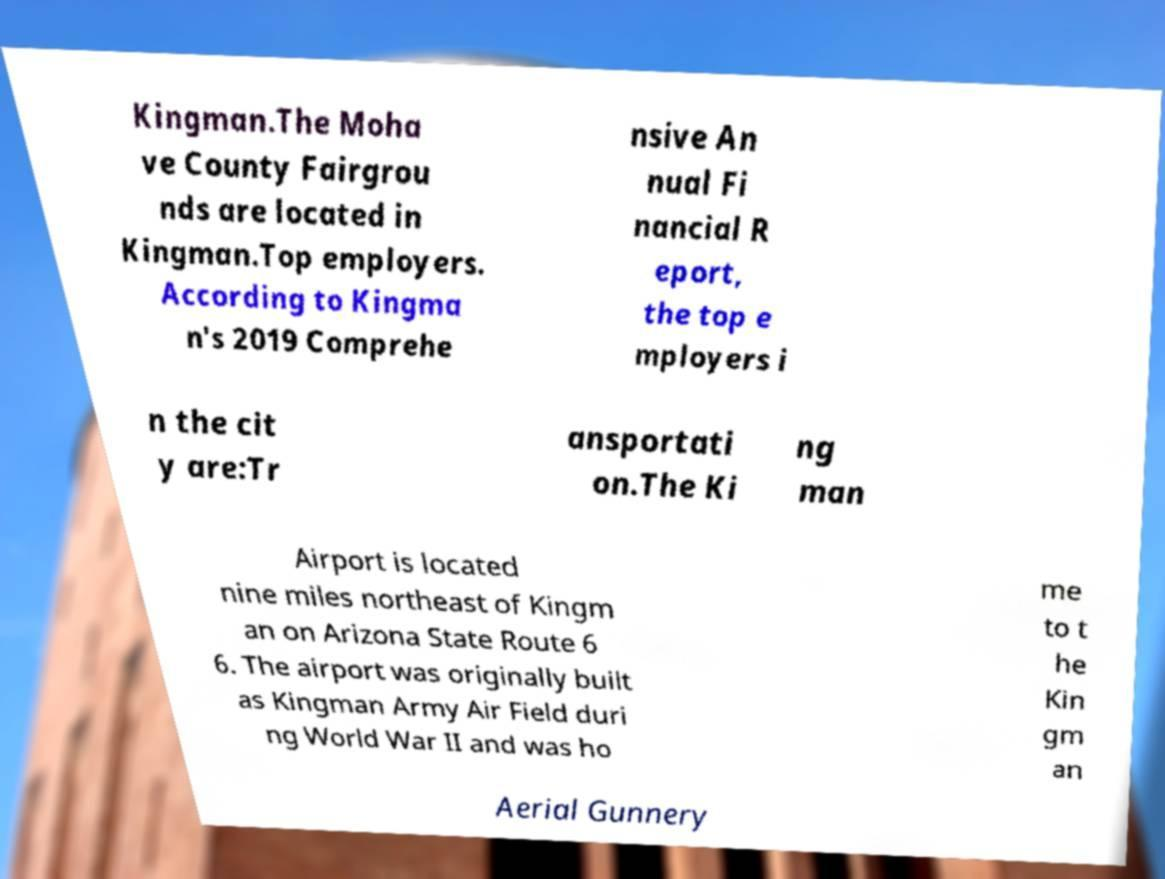I need the written content from this picture converted into text. Can you do that? Kingman.The Moha ve County Fairgrou nds are located in Kingman.Top employers. According to Kingma n's 2019 Comprehe nsive An nual Fi nancial R eport, the top e mployers i n the cit y are:Tr ansportati on.The Ki ng man Airport is located nine miles northeast of Kingm an on Arizona State Route 6 6. The airport was originally built as Kingman Army Air Field duri ng World War II and was ho me to t he Kin gm an Aerial Gunnery 